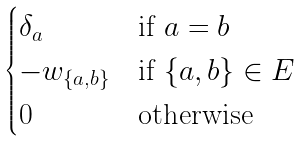Convert formula to latex. <formula><loc_0><loc_0><loc_500><loc_500>\begin{cases} \delta _ { a } & \text {if } a = b \\ - w _ { \{ a , b \} } & \text {if } \{ a , b \} \in E \\ 0 & \text {otherwise } \end{cases}</formula> 